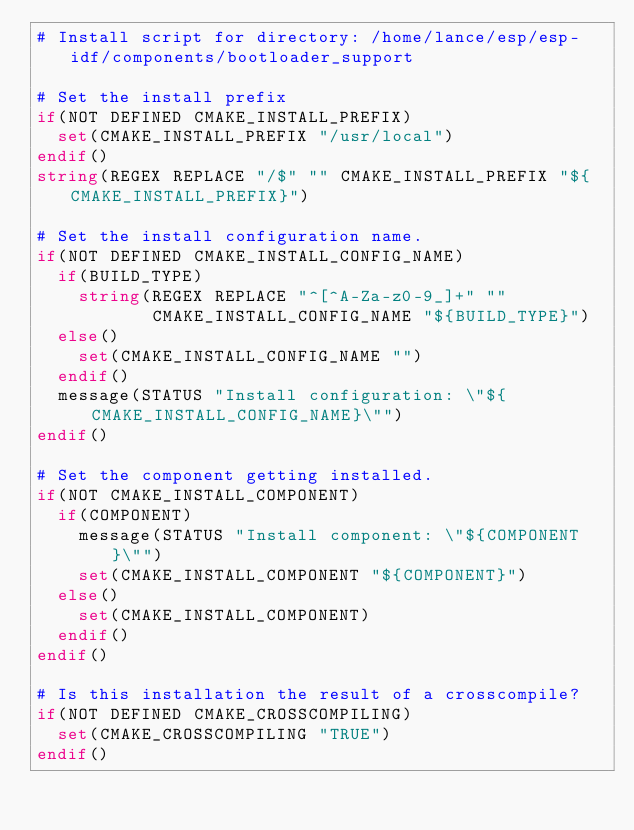<code> <loc_0><loc_0><loc_500><loc_500><_CMake_># Install script for directory: /home/lance/esp/esp-idf/components/bootloader_support

# Set the install prefix
if(NOT DEFINED CMAKE_INSTALL_PREFIX)
  set(CMAKE_INSTALL_PREFIX "/usr/local")
endif()
string(REGEX REPLACE "/$" "" CMAKE_INSTALL_PREFIX "${CMAKE_INSTALL_PREFIX}")

# Set the install configuration name.
if(NOT DEFINED CMAKE_INSTALL_CONFIG_NAME)
  if(BUILD_TYPE)
    string(REGEX REPLACE "^[^A-Za-z0-9_]+" ""
           CMAKE_INSTALL_CONFIG_NAME "${BUILD_TYPE}")
  else()
    set(CMAKE_INSTALL_CONFIG_NAME "")
  endif()
  message(STATUS "Install configuration: \"${CMAKE_INSTALL_CONFIG_NAME}\"")
endif()

# Set the component getting installed.
if(NOT CMAKE_INSTALL_COMPONENT)
  if(COMPONENT)
    message(STATUS "Install component: \"${COMPONENT}\"")
    set(CMAKE_INSTALL_COMPONENT "${COMPONENT}")
  else()
    set(CMAKE_INSTALL_COMPONENT)
  endif()
endif()

# Is this installation the result of a crosscompile?
if(NOT DEFINED CMAKE_CROSSCOMPILING)
  set(CMAKE_CROSSCOMPILING "TRUE")
endif()

</code> 